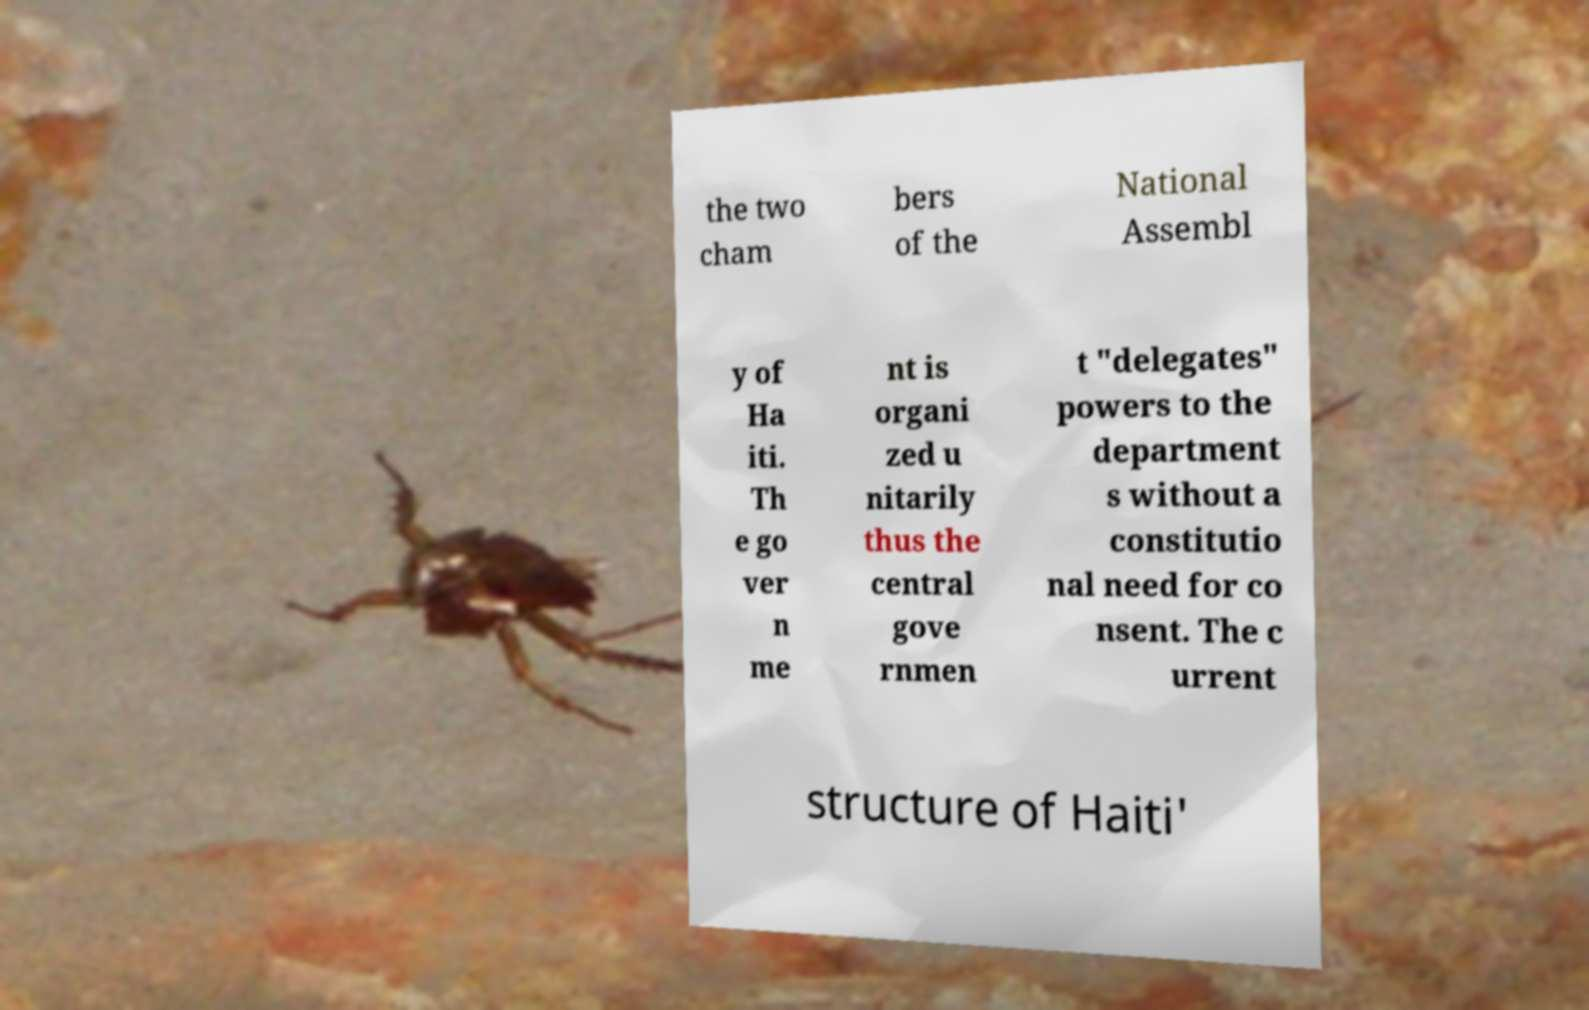Could you extract and type out the text from this image? the two cham bers of the National Assembl y of Ha iti. Th e go ver n me nt is organi zed u nitarily thus the central gove rnmen t "delegates" powers to the department s without a constitutio nal need for co nsent. The c urrent structure of Haiti' 